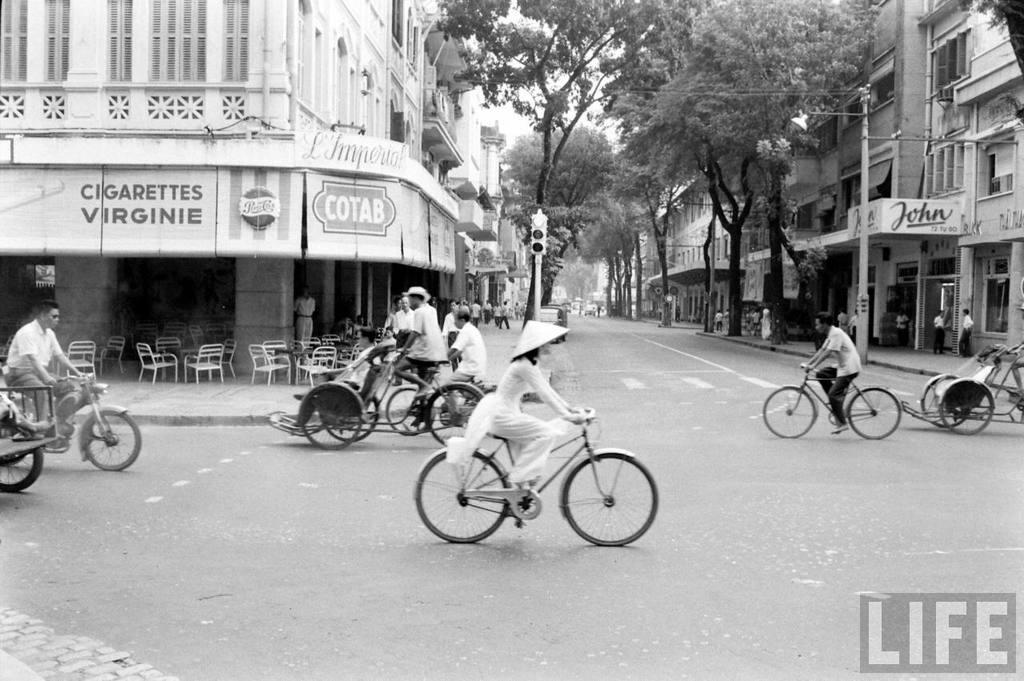In one or two sentences, can you explain what this image depicts? On the left there is a building. There are people riding bicycle on the road. In the background there are trees. There is a traffic light. There are some people standing near the building. 